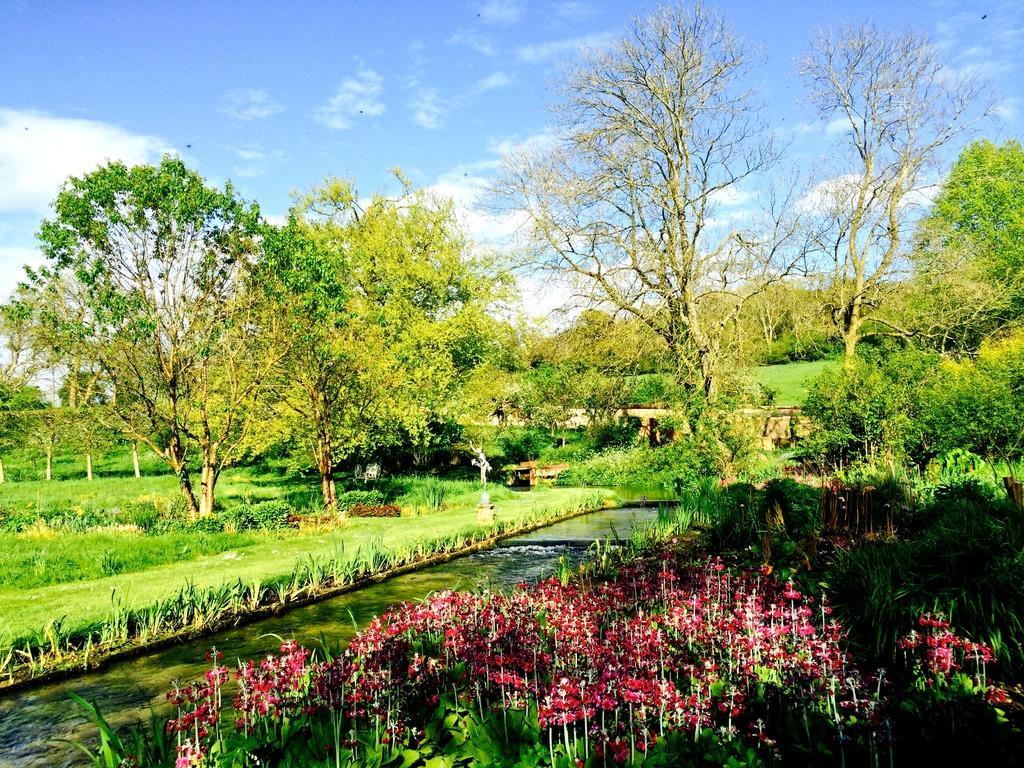Can you describe this image briefly? In this image, we can see trees, plants and there are flowers and we can see a bridge. At the top, there are clouds in the sky and at the bottom, there is water. 